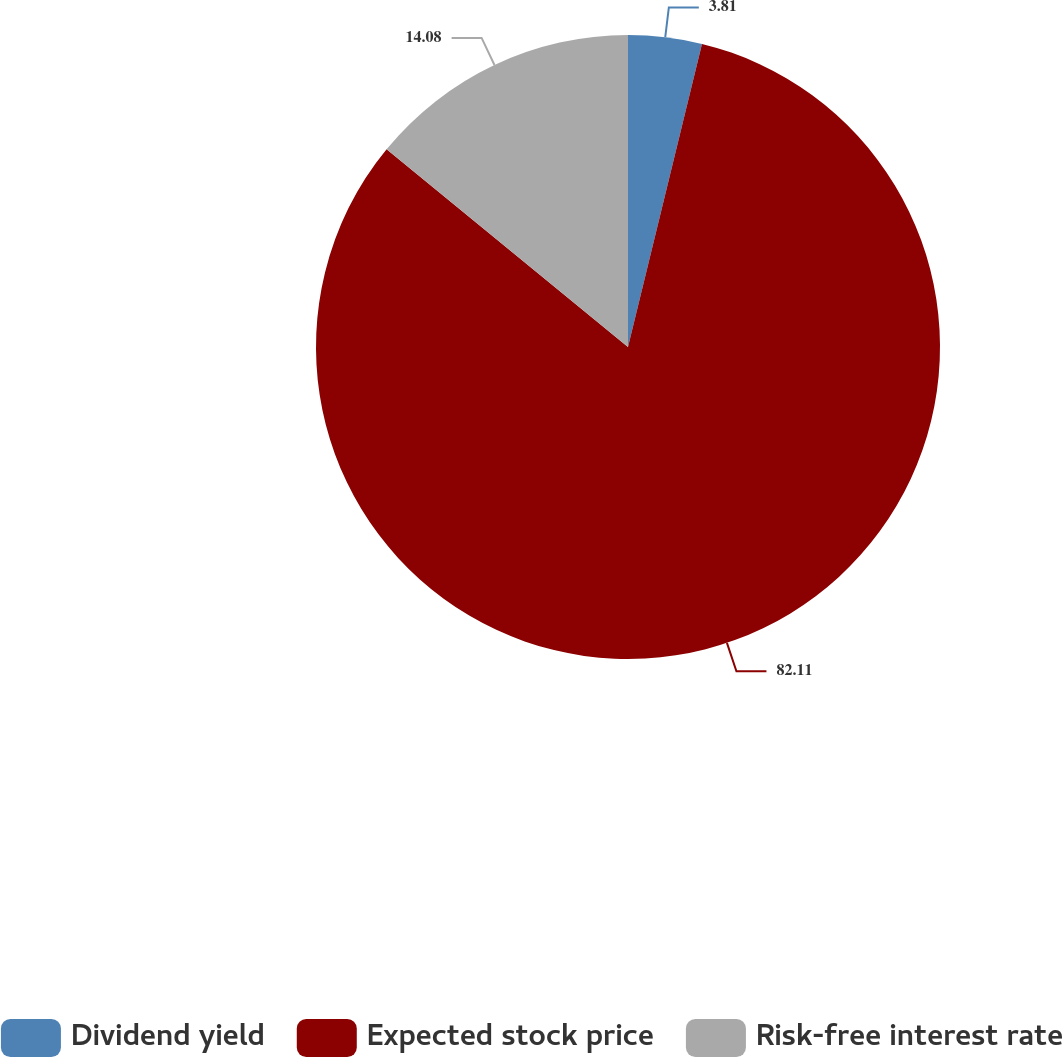<chart> <loc_0><loc_0><loc_500><loc_500><pie_chart><fcel>Dividend yield<fcel>Expected stock price<fcel>Risk-free interest rate<nl><fcel>3.81%<fcel>82.11%<fcel>14.08%<nl></chart> 